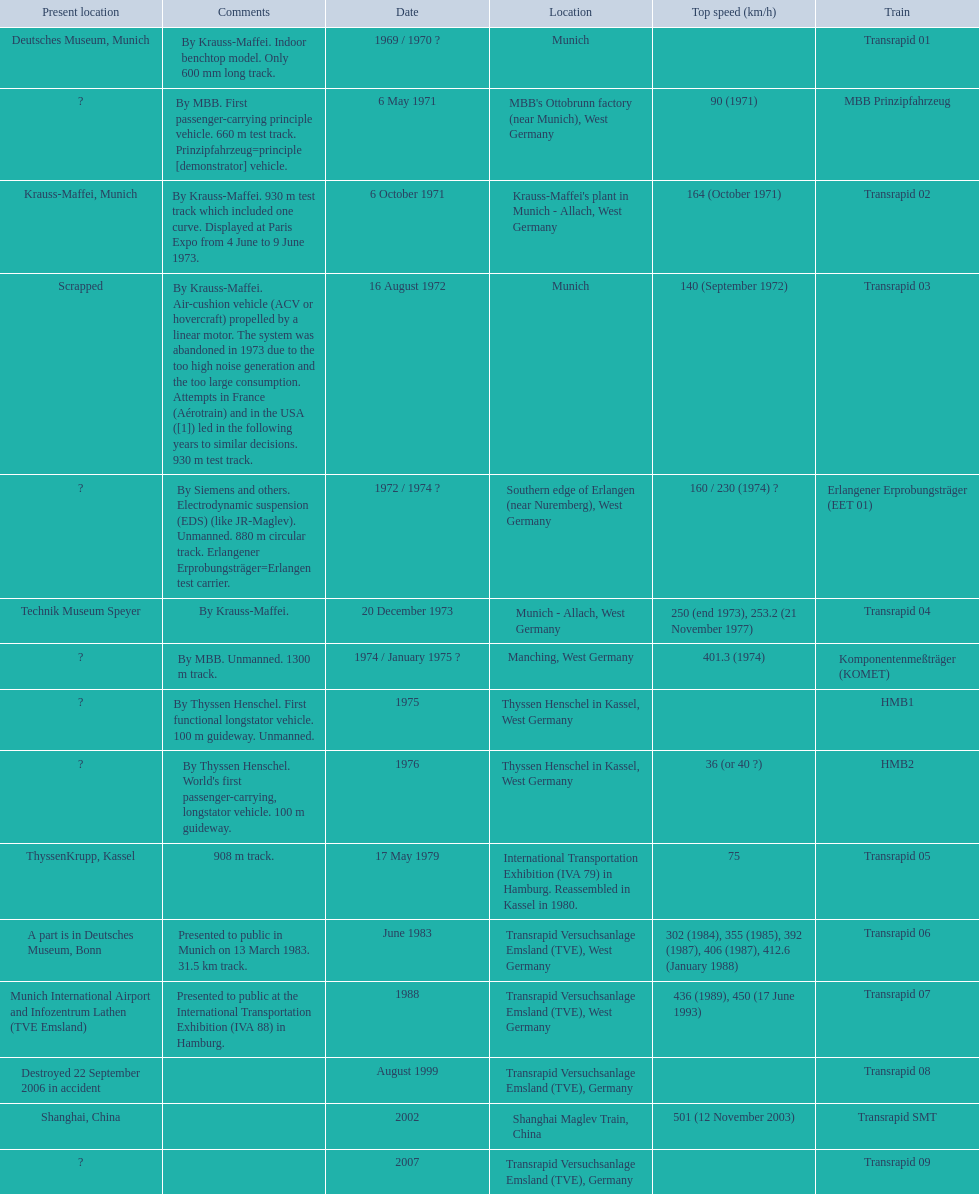Which trains exceeded a top speed of 400+? Komponentenmeßträger (KOMET), Transrapid 07, Transrapid SMT. How about 500+? Transrapid SMT. 